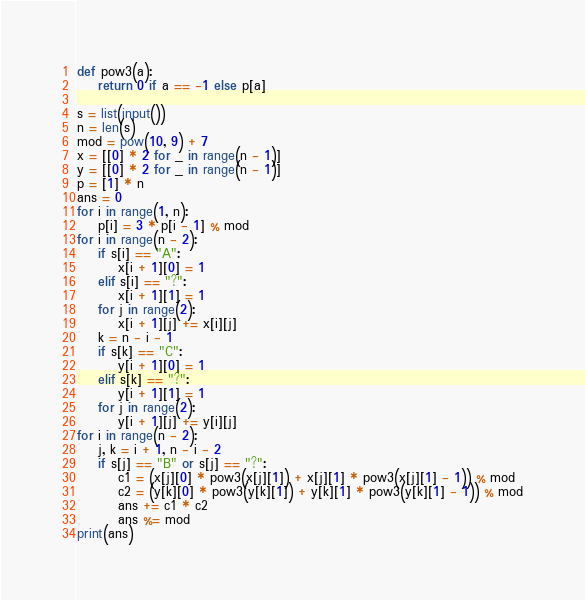Convert code to text. <code><loc_0><loc_0><loc_500><loc_500><_Python_>def pow3(a):
    return 0 if a == -1 else p[a]

s = list(input())
n = len(s)
mod = pow(10, 9) + 7
x = [[0] * 2 for _ in range(n - 1)]
y = [[0] * 2 for _ in range(n - 1)]
p = [1] * n
ans = 0
for i in range(1, n):
    p[i] = 3 * p[i - 1] % mod
for i in range(n - 2):
    if s[i] == "A":
        x[i + 1][0] = 1
    elif s[i] == "?":
        x[i + 1][1] = 1
    for j in range(2):
        x[i + 1][j] += x[i][j]
    k = n - i - 1
    if s[k] == "C":
        y[i + 1][0] = 1
    elif s[k] == "?":
        y[i + 1][1] = 1
    for j in range(2):
        y[i + 1][j] += y[i][j]
for i in range(n - 2):
    j, k = i + 1, n - i - 2
    if s[j] == "B" or s[j] == "?":
        c1 = (x[j][0] * pow3(x[j][1]) + x[j][1] * pow3(x[j][1] - 1)) % mod
        c2 = (y[k][0] * pow3(y[k][1]) + y[k][1] * pow3(y[k][1] - 1)) % mod
        ans += c1 * c2
        ans %= mod
print(ans)</code> 